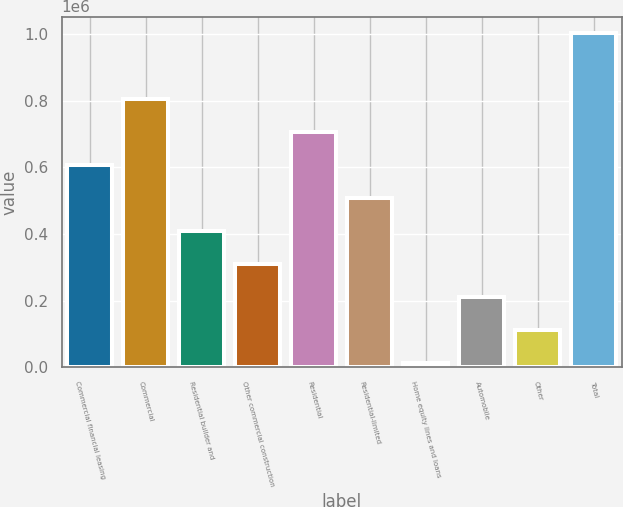Convert chart to OTSL. <chart><loc_0><loc_0><loc_500><loc_500><bar_chart><fcel>Commercial financial leasing<fcel>Commercial<fcel>Residential builder and<fcel>Other commercial construction<fcel>Residential<fcel>Residential-limited<fcel>Home equity lines and loans<fcel>Automobile<fcel>Other<fcel>Total<nl><fcel>606109<fcel>803875<fcel>408343<fcel>309460<fcel>704992<fcel>507226<fcel>12811<fcel>210577<fcel>111694<fcel>1.00164e+06<nl></chart> 